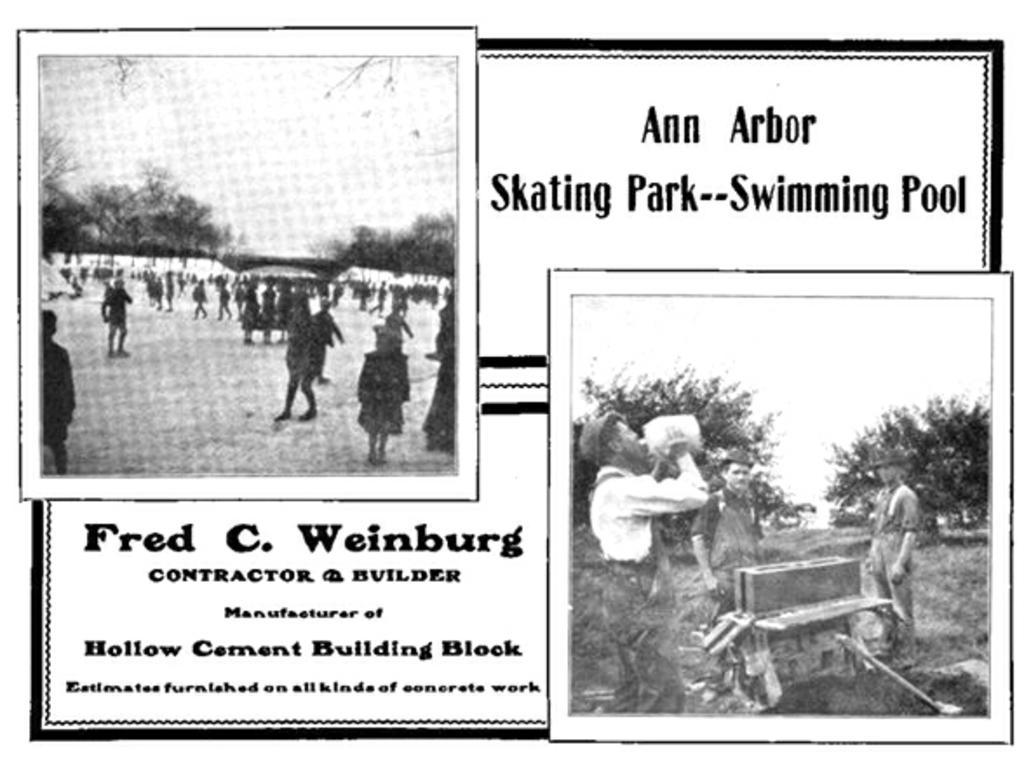Describe this image in one or two sentences. There are two black and white pic photographs on the black and white poster where texts are written on the poster. On the left side photo we can see few persons are standing and walking on the ground and in the background there are trees and sky and on the right side photo we can see a person is holding a water can in the hands at the mouth and two men are standing at the wooden and in the background there are trees and sky. 